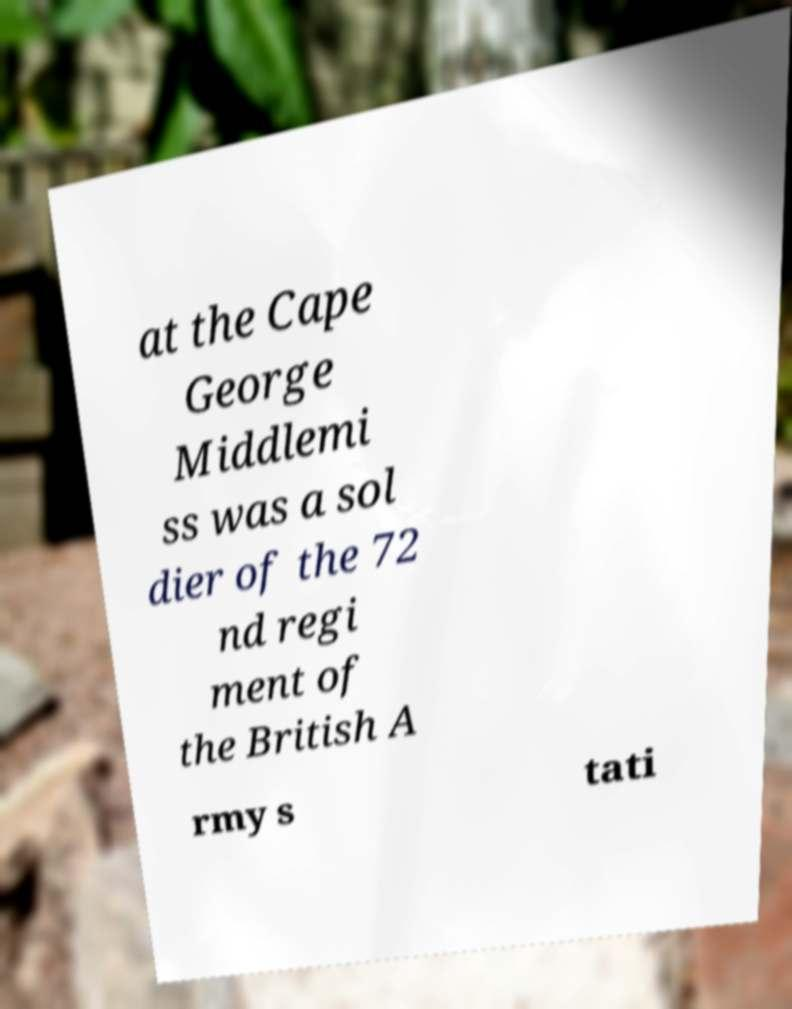Can you read and provide the text displayed in the image?This photo seems to have some interesting text. Can you extract and type it out for me? at the Cape George Middlemi ss was a sol dier of the 72 nd regi ment of the British A rmy s tati 